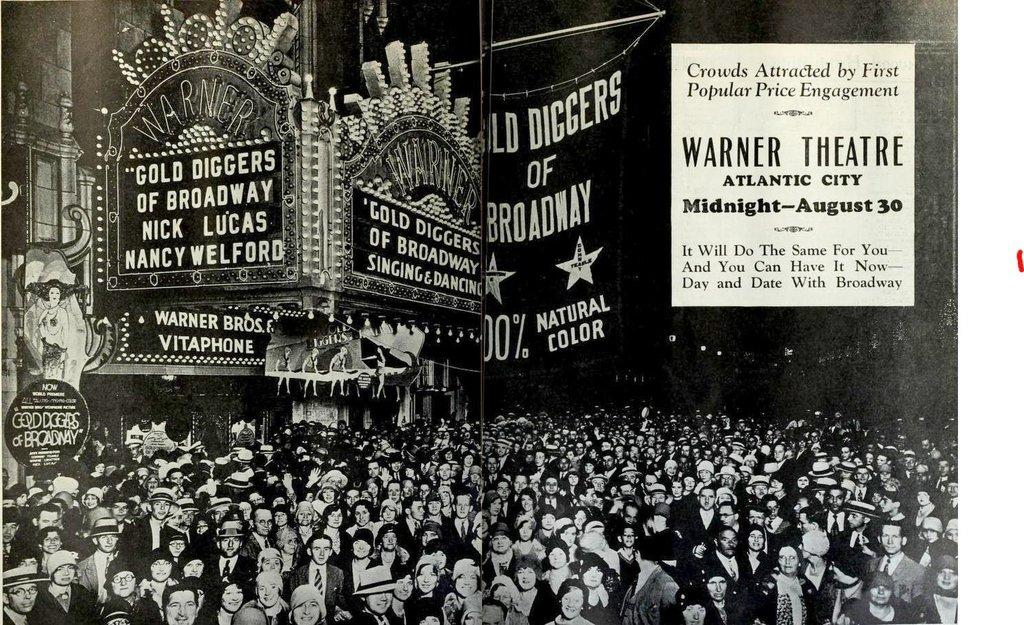<image>
Share a concise interpretation of the image provided. A large crowd is below several banners, one of which advertises "Gold Diggers of Broadway." 